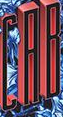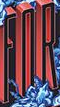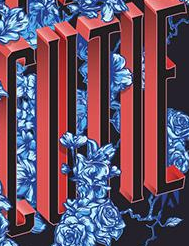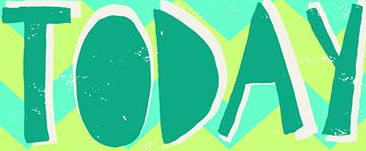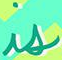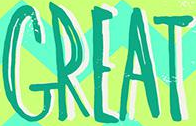Read the text from these images in sequence, separated by a semicolon. CAB; FOR; CUTIE; TODAY; is; GREAT 